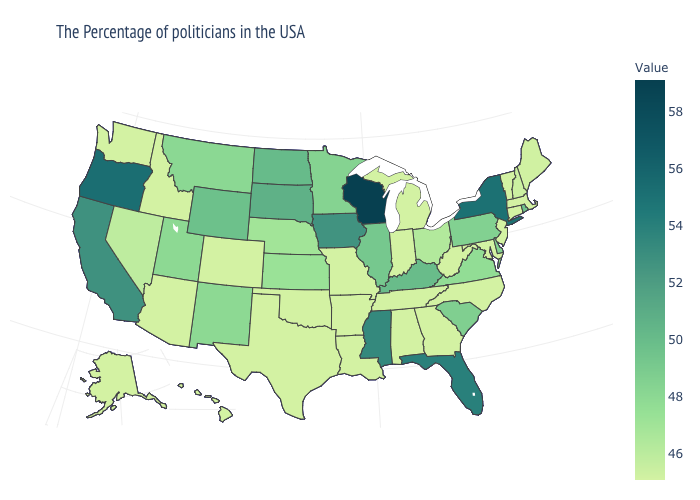Does Oregon have the highest value in the West?
Be succinct. Yes. Which states have the highest value in the USA?
Short answer required. Wisconsin. Does North Carolina have the highest value in the South?
Write a very short answer. No. Which states have the highest value in the USA?
Answer briefly. Wisconsin. Among the states that border Arkansas , which have the lowest value?
Write a very short answer. Tennessee, Louisiana, Missouri, Oklahoma, Texas. Which states have the lowest value in the USA?
Short answer required. Massachusetts, Vermont, Connecticut, New Jersey, Maryland, North Carolina, West Virginia, Georgia, Michigan, Indiana, Alabama, Tennessee, Louisiana, Missouri, Arkansas, Oklahoma, Texas, Colorado, Arizona, Idaho, Washington, Alaska, Hawaii. 